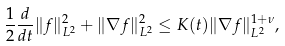Convert formula to latex. <formula><loc_0><loc_0><loc_500><loc_500>\frac { 1 } { 2 } \frac { d } { d t } \| f \| ^ { 2 } _ { L ^ { 2 } } + \| \nabla { f } \| ^ { 2 } _ { L ^ { 2 } } \leq K ( t ) \| \nabla f \| _ { L ^ { 2 } } ^ { 1 + \nu } ,</formula> 